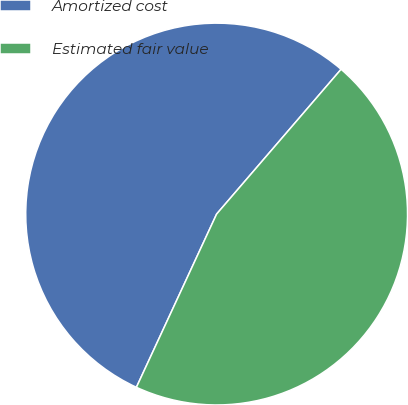<chart> <loc_0><loc_0><loc_500><loc_500><pie_chart><fcel>Amortized cost<fcel>Estimated fair value<nl><fcel>54.4%<fcel>45.6%<nl></chart> 